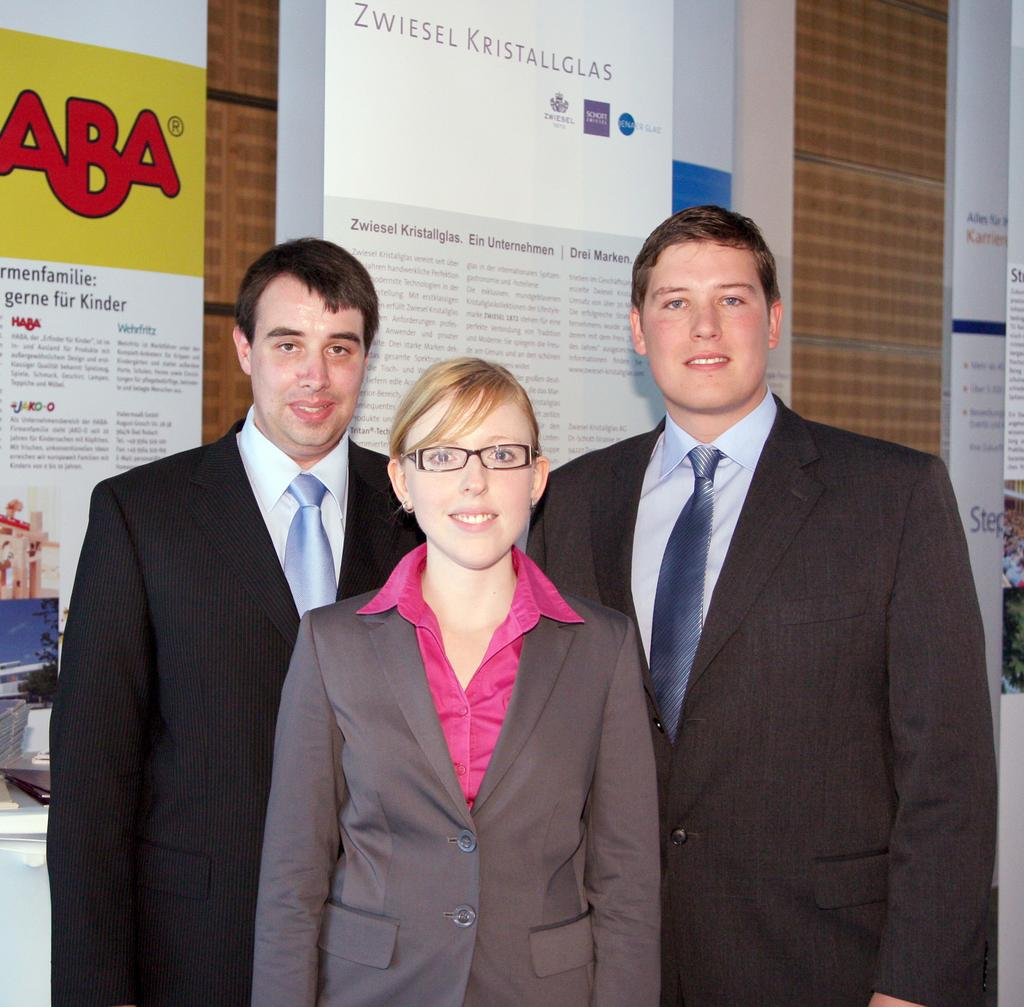How many people are in the image? There are 3 people in the image. What are the people wearing? The people are wearing suits. Can you describe the person at the center? The person at the center is wearing spectacles and a pink shirt. What can be seen in the background of the image? There are posters visible in the background. What type of harmony can be heard in the image? There is no audible sound or music in the image, so it is not possible to determine if there is any harmony present. 